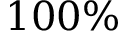<formula> <loc_0><loc_0><loc_500><loc_500>1 0 0 \%</formula> 